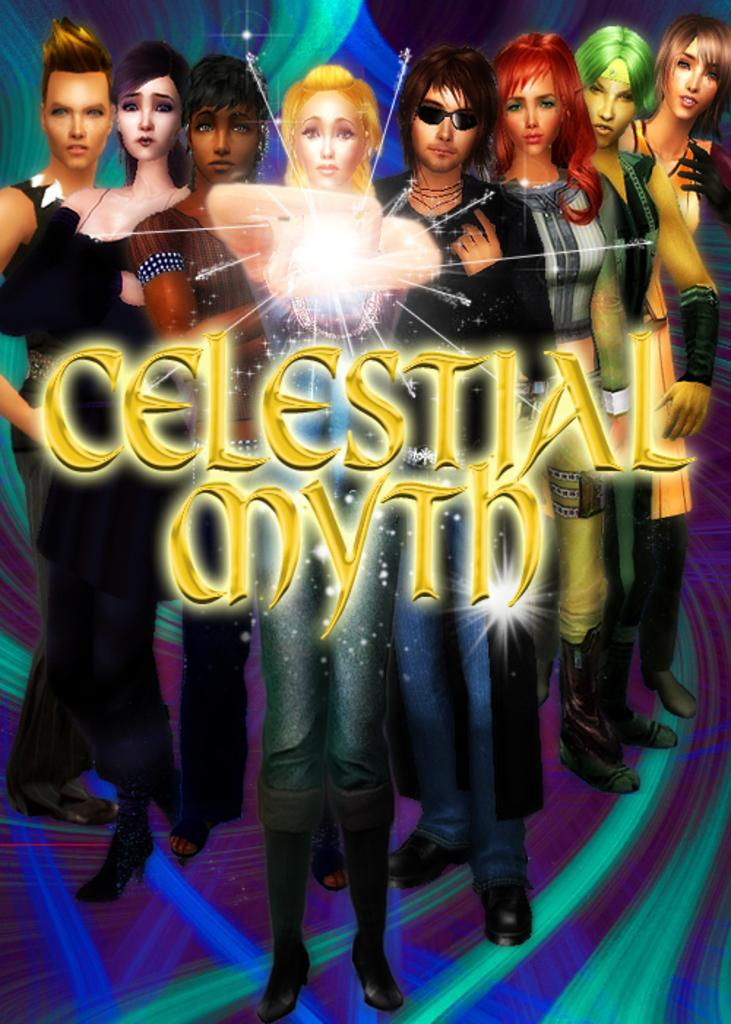How many animated characters are present in the image? There are eight animated characters in the image. What is written in the middle of the image? The text in the middle of the image says "celestial myth." Can you see a squirrel holding a ball on a wire in the image? There is no squirrel, ball, or wire present in the image. 